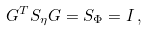<formula> <loc_0><loc_0><loc_500><loc_500>{ G } ^ { T } { S } _ { \eta } { G } = { S } _ { \Phi } = { I } \, ,</formula> 